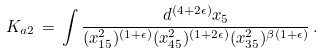<formula> <loc_0><loc_0><loc_500><loc_500>K _ { a 2 } \, = \, \int \frac { d ^ { ( 4 + 2 \epsilon ) } x _ { 5 } } { ( x ^ { 2 } _ { 1 5 } ) ^ { ( 1 + \epsilon ) } ( x ^ { 2 } _ { 4 5 } ) ^ { ( 1 + 2 \epsilon ) } ( x ^ { 2 } _ { 3 5 } ) ^ { \beta ( 1 + \epsilon ) } } \, .</formula> 